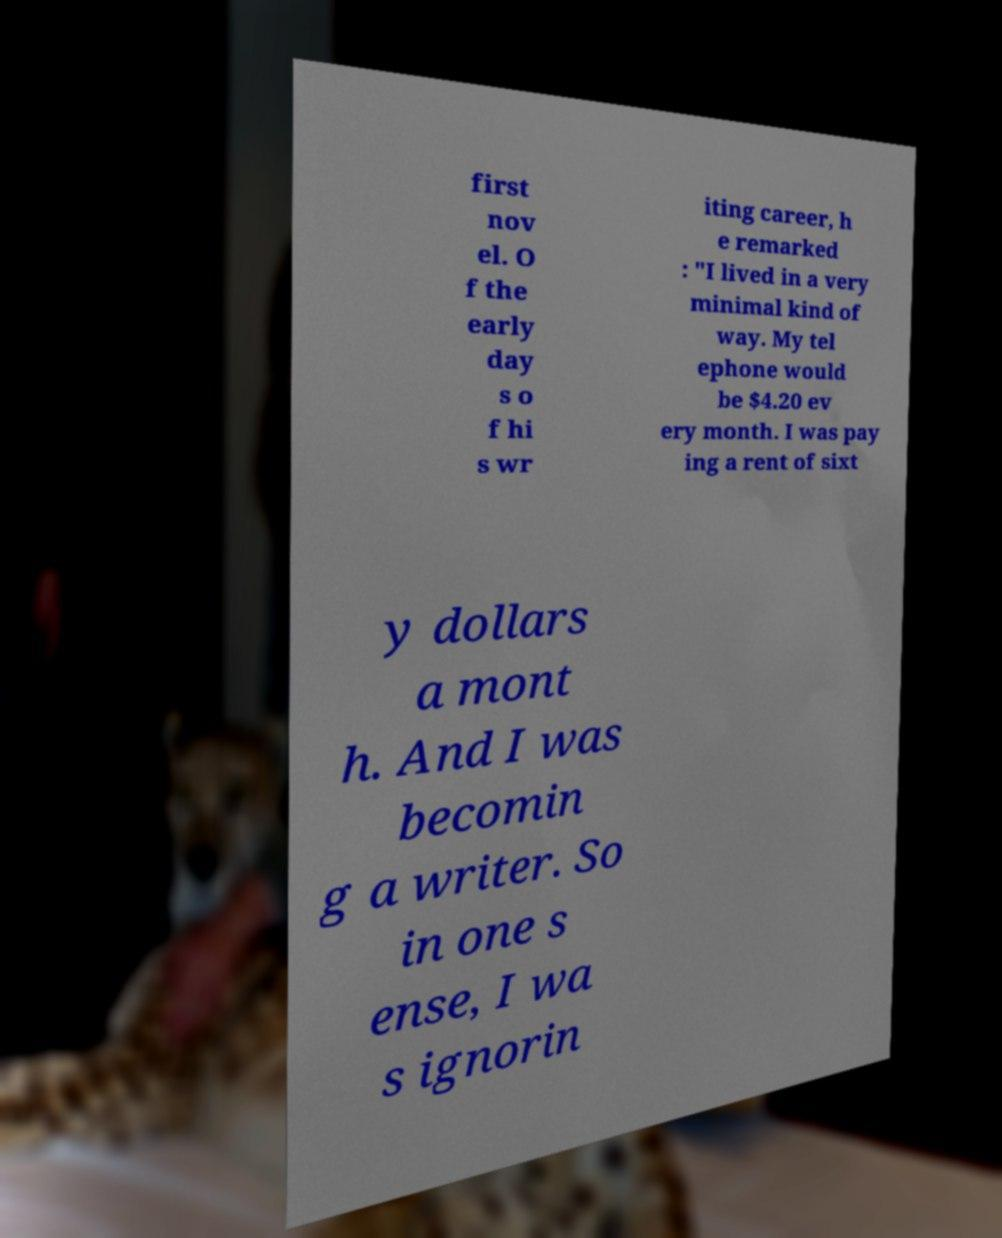Could you extract and type out the text from this image? first nov el. O f the early day s o f hi s wr iting career, h e remarked : "I lived in a very minimal kind of way. My tel ephone would be $4.20 ev ery month. I was pay ing a rent of sixt y dollars a mont h. And I was becomin g a writer. So in one s ense, I wa s ignorin 